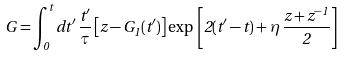Convert formula to latex. <formula><loc_0><loc_0><loc_500><loc_500>G = \int _ { 0 } ^ { t } d t ^ { \prime } \, \frac { t ^ { \prime } } { \tau } \left [ z - G _ { 1 } ( t ^ { \prime } ) \right ] \exp \, \left [ 2 ( t ^ { \prime } - t ) + \eta \, \frac { z + z ^ { - 1 } } { 2 } \right ]</formula> 